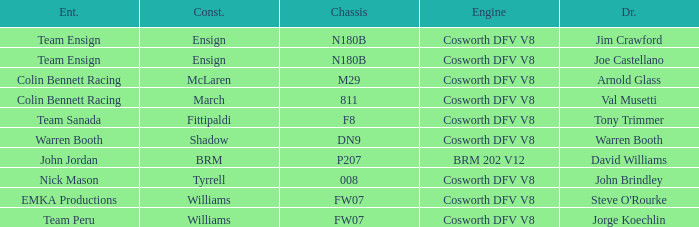What team uses a Cosworth DFV V8 engine and DN9 Chassis? Warren Booth. I'm looking to parse the entire table for insights. Could you assist me with that? {'header': ['Ent.', 'Const.', 'Chassis', 'Engine', 'Dr.'], 'rows': [['Team Ensign', 'Ensign', 'N180B', 'Cosworth DFV V8', 'Jim Crawford'], ['Team Ensign', 'Ensign', 'N180B', 'Cosworth DFV V8', 'Joe Castellano'], ['Colin Bennett Racing', 'McLaren', 'M29', 'Cosworth DFV V8', 'Arnold Glass'], ['Colin Bennett Racing', 'March', '811', 'Cosworth DFV V8', 'Val Musetti'], ['Team Sanada', 'Fittipaldi', 'F8', 'Cosworth DFV V8', 'Tony Trimmer'], ['Warren Booth', 'Shadow', 'DN9', 'Cosworth DFV V8', 'Warren Booth'], ['John Jordan', 'BRM', 'P207', 'BRM 202 V12', 'David Williams'], ['Nick Mason', 'Tyrrell', '008', 'Cosworth DFV V8', 'John Brindley'], ['EMKA Productions', 'Williams', 'FW07', 'Cosworth DFV V8', "Steve O'Rourke"], ['Team Peru', 'Williams', 'FW07', 'Cosworth DFV V8', 'Jorge Koechlin']]} 